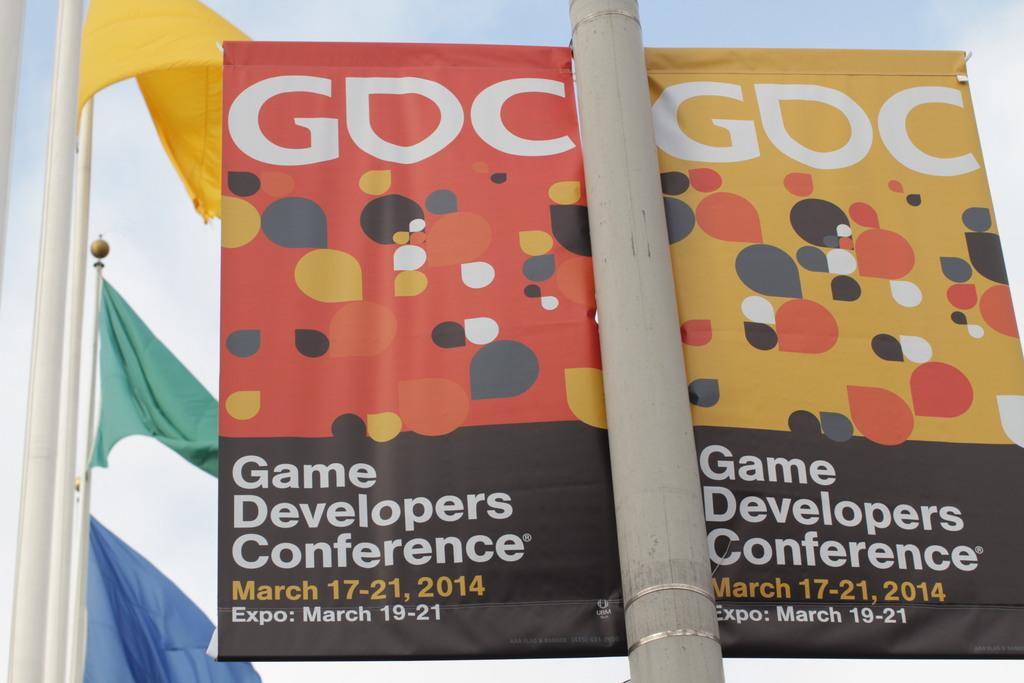<image>
Write a terse but informative summary of the picture. A double sided sign on a pole for the Game Developers Conference. 